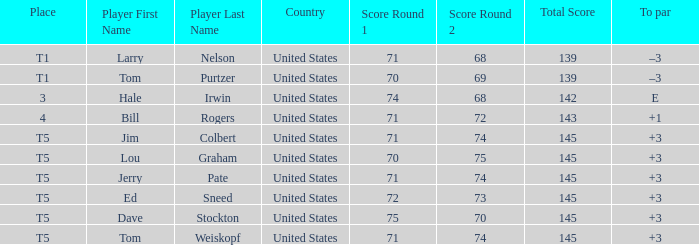What is the country of player ed sneed with a to par of +3? United States. 